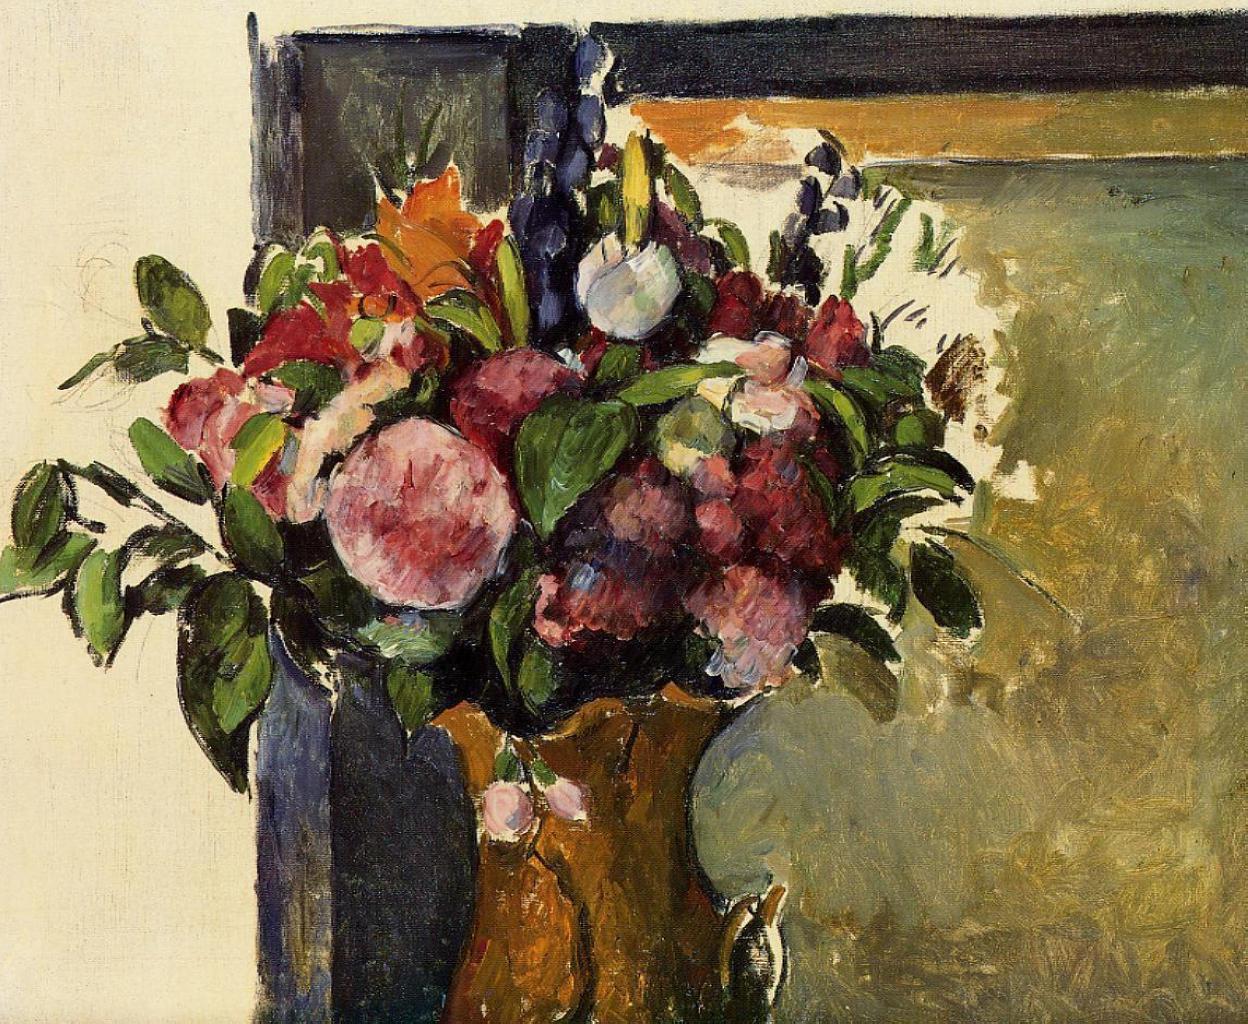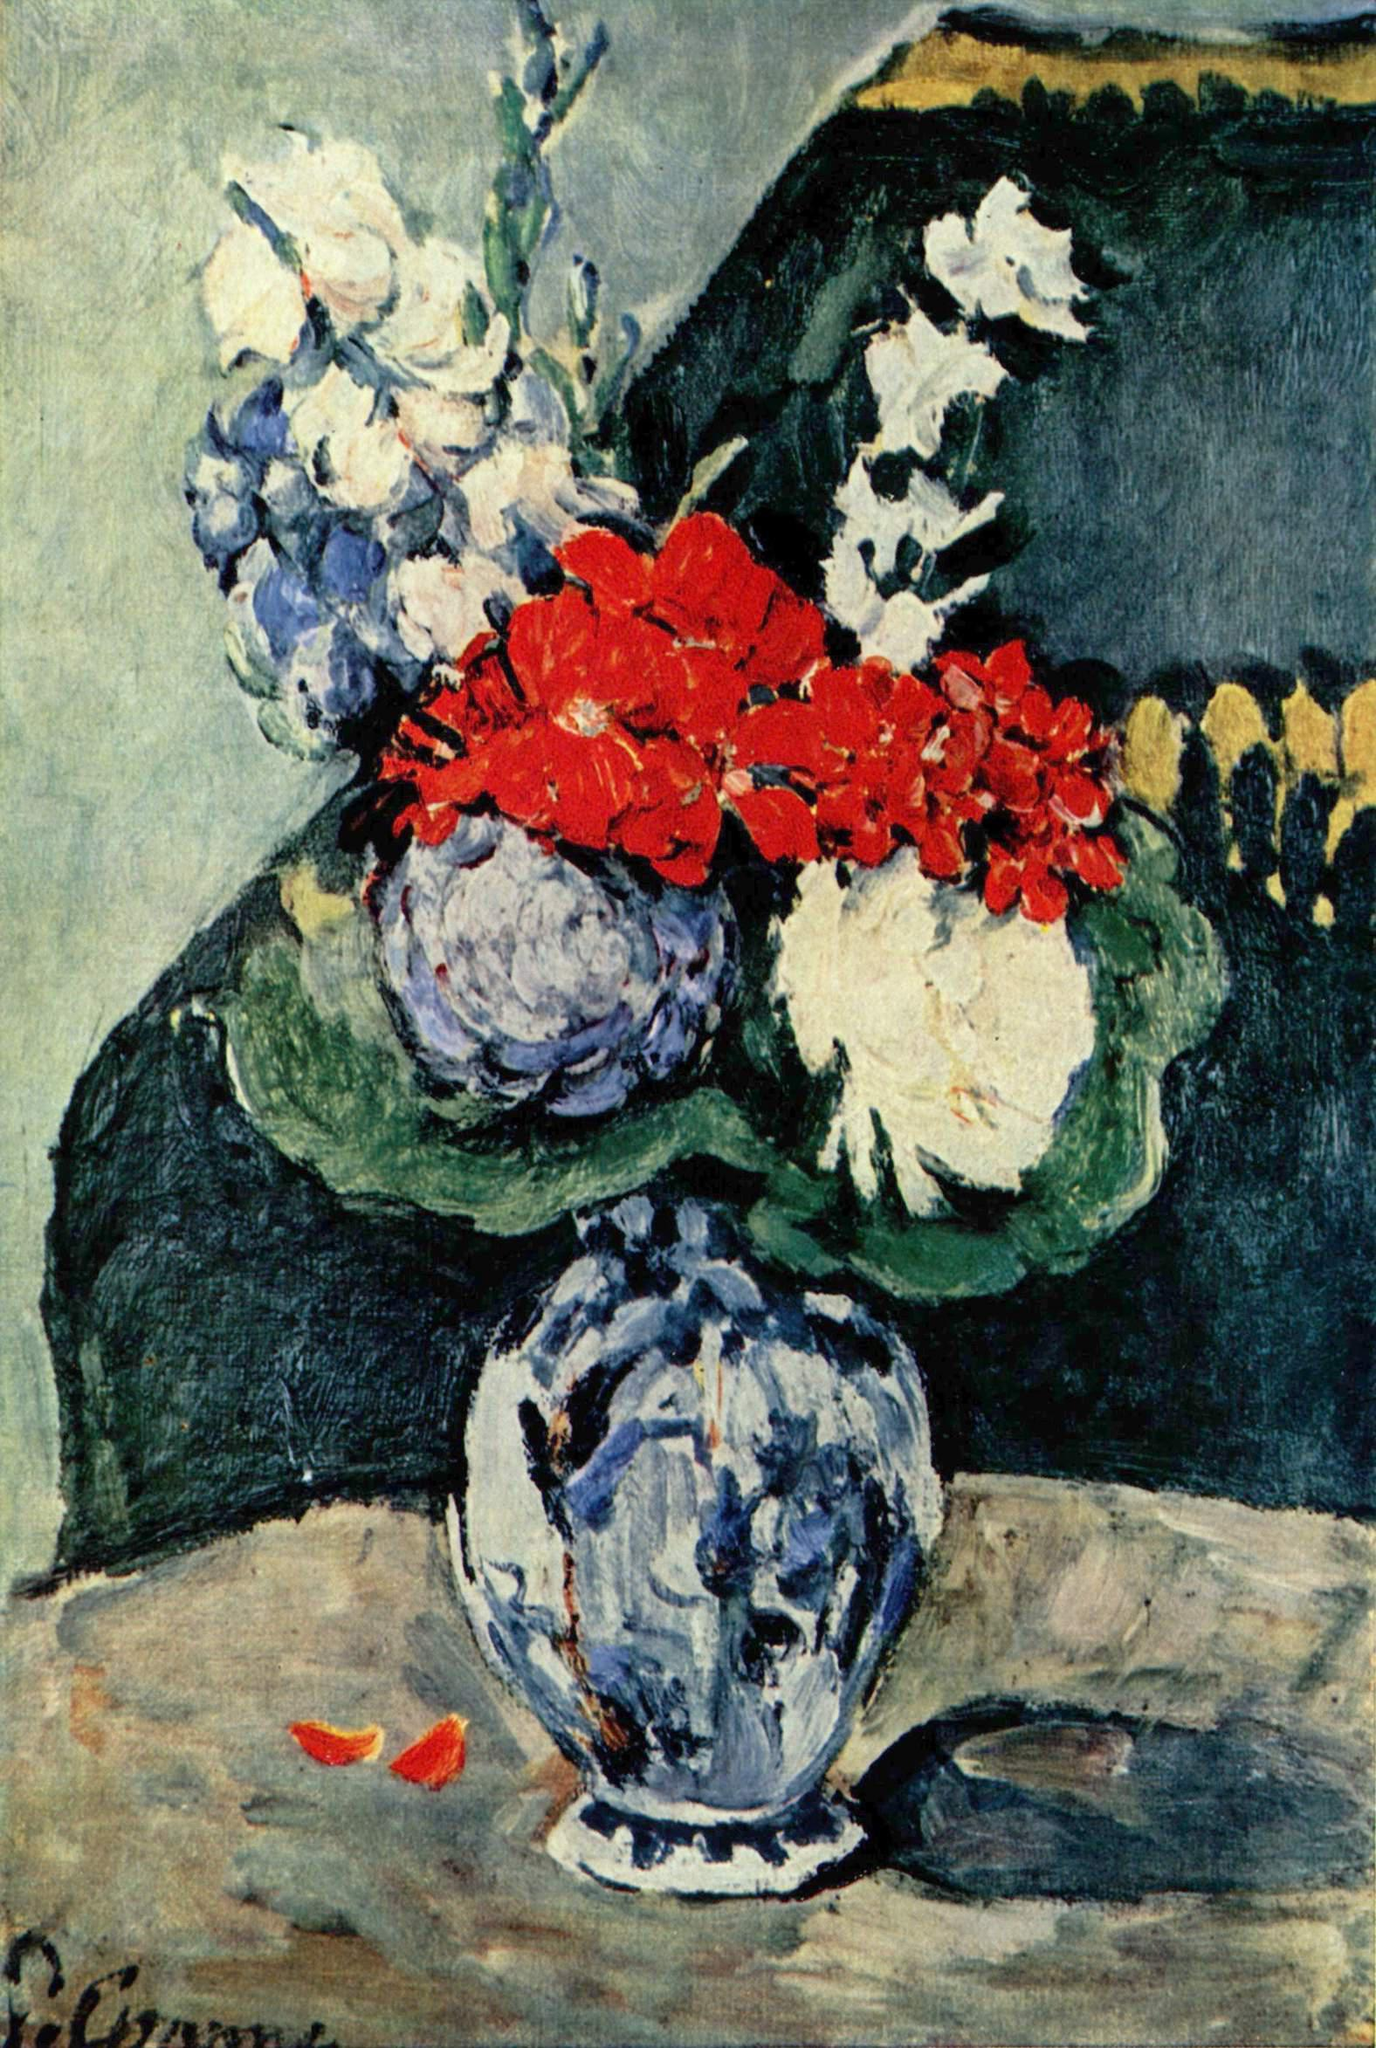The first image is the image on the left, the second image is the image on the right. Given the left and right images, does the statement "In one image there is a vase of flowers next to several pieces of fruit on a tabletop." hold true? Answer yes or no. No. The first image is the image on the left, the second image is the image on the right. For the images displayed, is the sentence "One of the pictures shows a vase on a table with at least three round fruit also displayed on the table." factually correct? Answer yes or no. No. 